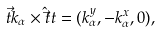Convert formula to latex. <formula><loc_0><loc_0><loc_500><loc_500>\vec { t } { k } _ { \alpha } \times \hat { \vec } t { t } = ( k _ { \alpha } ^ { y } , - k _ { \alpha } ^ { x } , 0 ) ,</formula> 